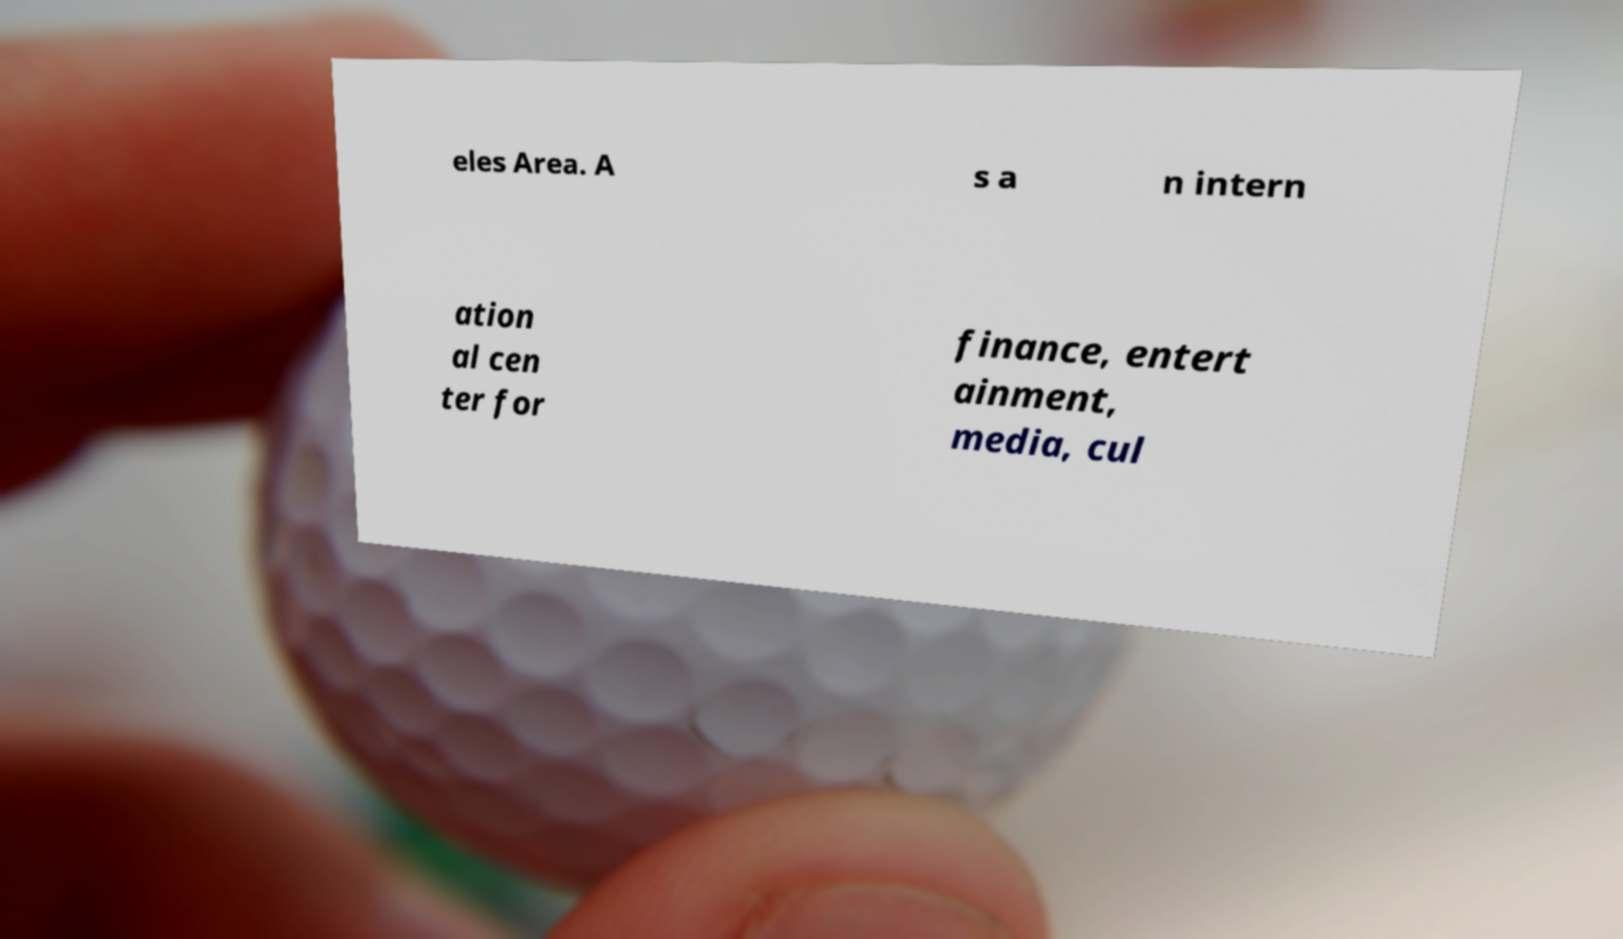Can you accurately transcribe the text from the provided image for me? eles Area. A s a n intern ation al cen ter for finance, entert ainment, media, cul 